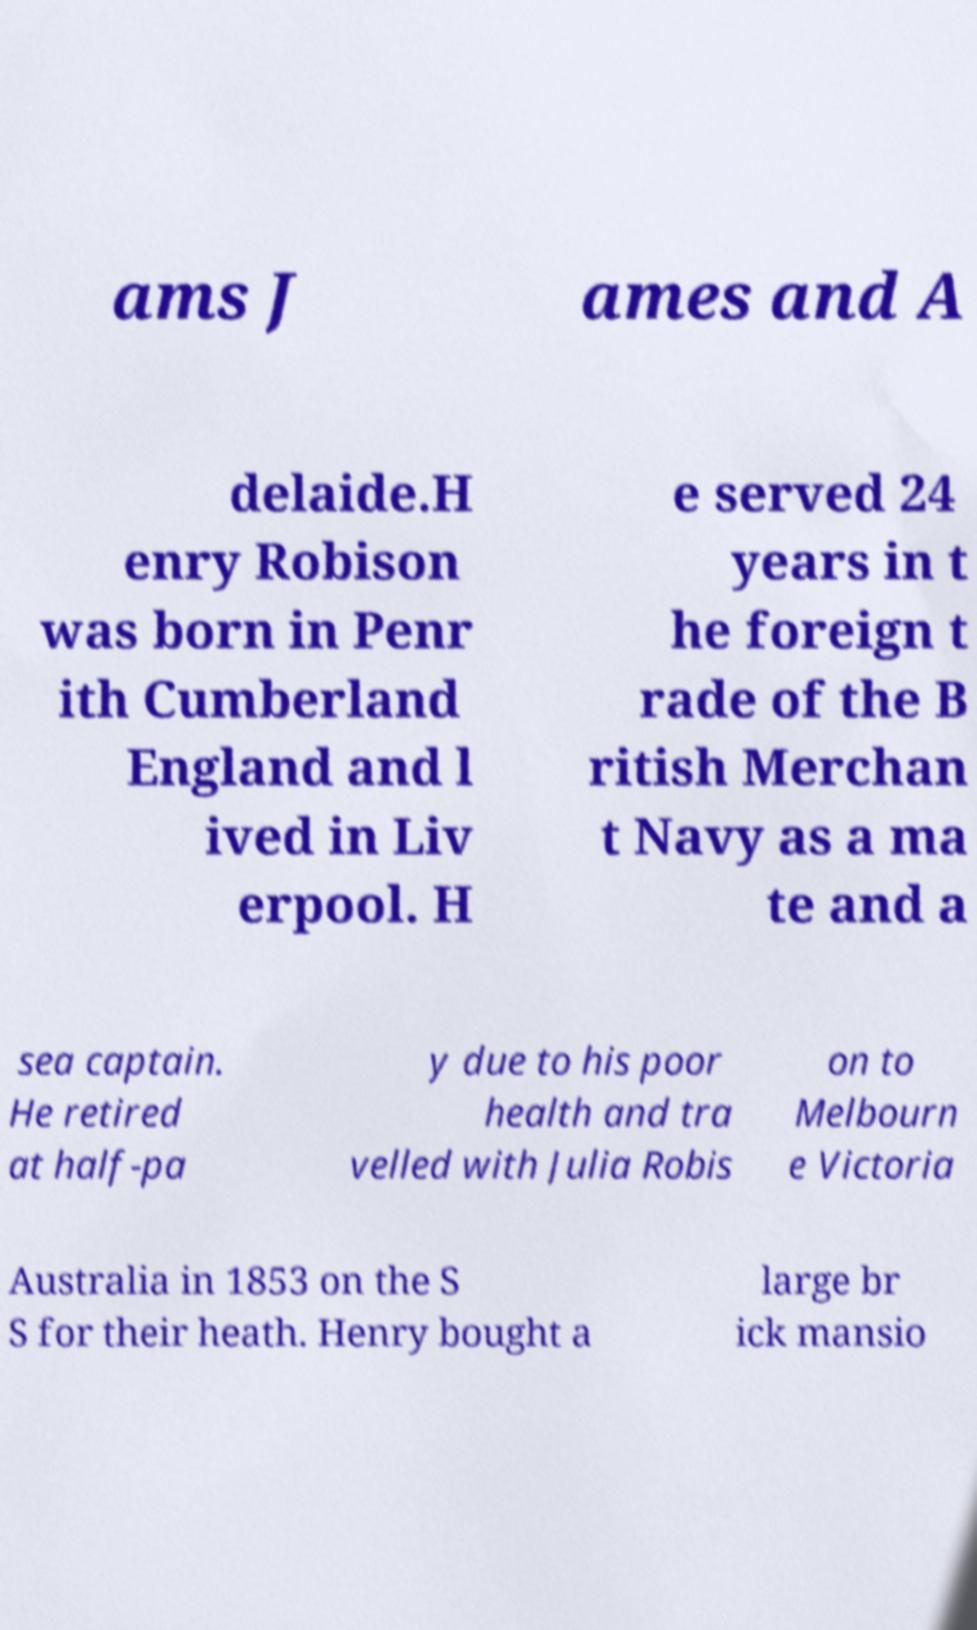Please identify and transcribe the text found in this image. ams J ames and A delaide.H enry Robison was born in Penr ith Cumberland England and l ived in Liv erpool. H e served 24 years in t he foreign t rade of the B ritish Merchan t Navy as a ma te and a sea captain. He retired at half-pa y due to his poor health and tra velled with Julia Robis on to Melbourn e Victoria Australia in 1853 on the S S for their heath. Henry bought a large br ick mansio 